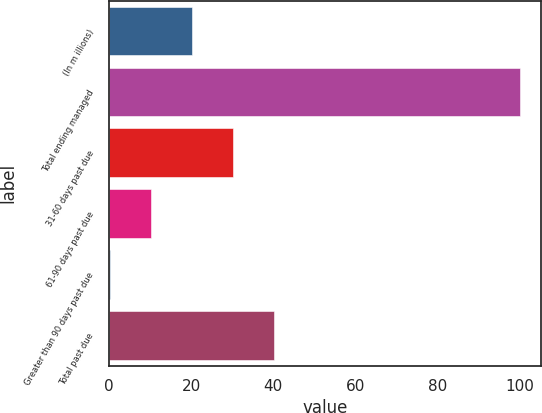Convert chart. <chart><loc_0><loc_0><loc_500><loc_500><bar_chart><fcel>(In m illions)<fcel>Total ending managed<fcel>31-60 days past due<fcel>61-90 days past due<fcel>Greater than 90 days past due<fcel>Total past due<nl><fcel>20.16<fcel>100<fcel>30.14<fcel>10.18<fcel>0.2<fcel>40.12<nl></chart> 